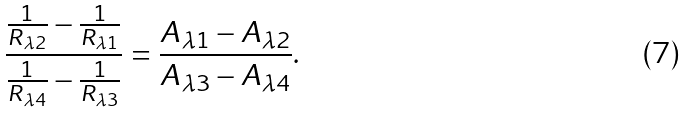<formula> <loc_0><loc_0><loc_500><loc_500>\frac { \frac { 1 } { R _ { \lambda 2 } } - \frac { 1 } { R _ { \lambda 1 } } } { \frac { 1 } { R _ { \lambda 4 } } - \frac { 1 } { R _ { \lambda 3 } } } = \frac { A _ { \lambda 1 } - A _ { \lambda 2 } } { A _ { \lambda 3 } - A _ { \lambda 4 } } .</formula> 